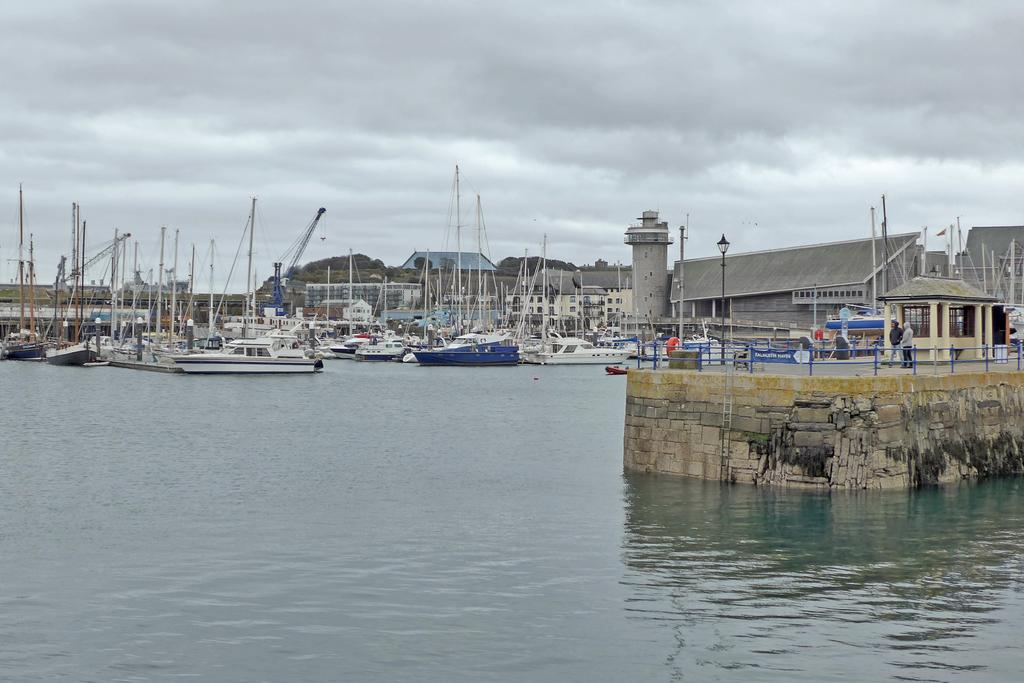What is on the surface of the water in the image? There are ships on the surface of the water in the image. What can be seen in the background of the image? There are buildings and trees in the background of the image. What is visible at the top of the image? The sky is visible at the top of the image. What can be observed in the sky? Clouds are present in the sky. Can you tell me which actor is standing on the ship in the image? There are no actors present in the image; it features ships on the water's surface. What type of lumber is being used to construct the buildings in the image? There is no information about the materials used to construct the buildings in the image. 